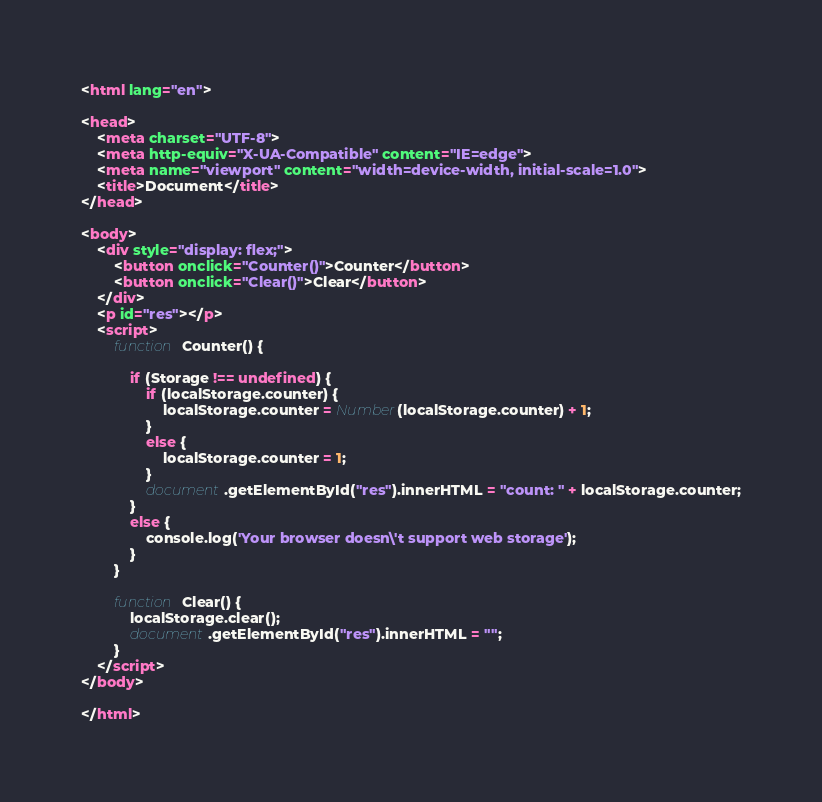<code> <loc_0><loc_0><loc_500><loc_500><_HTML_><html lang="en">

<head>
    <meta charset="UTF-8">
    <meta http-equiv="X-UA-Compatible" content="IE=edge">
    <meta name="viewport" content="width=device-width, initial-scale=1.0">
    <title>Document</title>
</head>

<body>
    <div style="display: flex;">
        <button onclick="Counter()">Counter</button>
        <button onclick="Clear()">Clear</button>
    </div>
    <p id="res"></p>
    <script>
        function Counter() {

            if (Storage !== undefined) {
                if (localStorage.counter) {
                    localStorage.counter = Number(localStorage.counter) + 1;
                }
                else {
                    localStorage.counter = 1;
                }
                document.getElementById("res").innerHTML = "count: " + localStorage.counter;
            }
            else {
                console.log('Your browser doesn\'t support web storage');
            }
        }

        function Clear() {
            localStorage.clear();
            document.getElementById("res").innerHTML = "";
        }
    </script>
</body>

</html></code> 